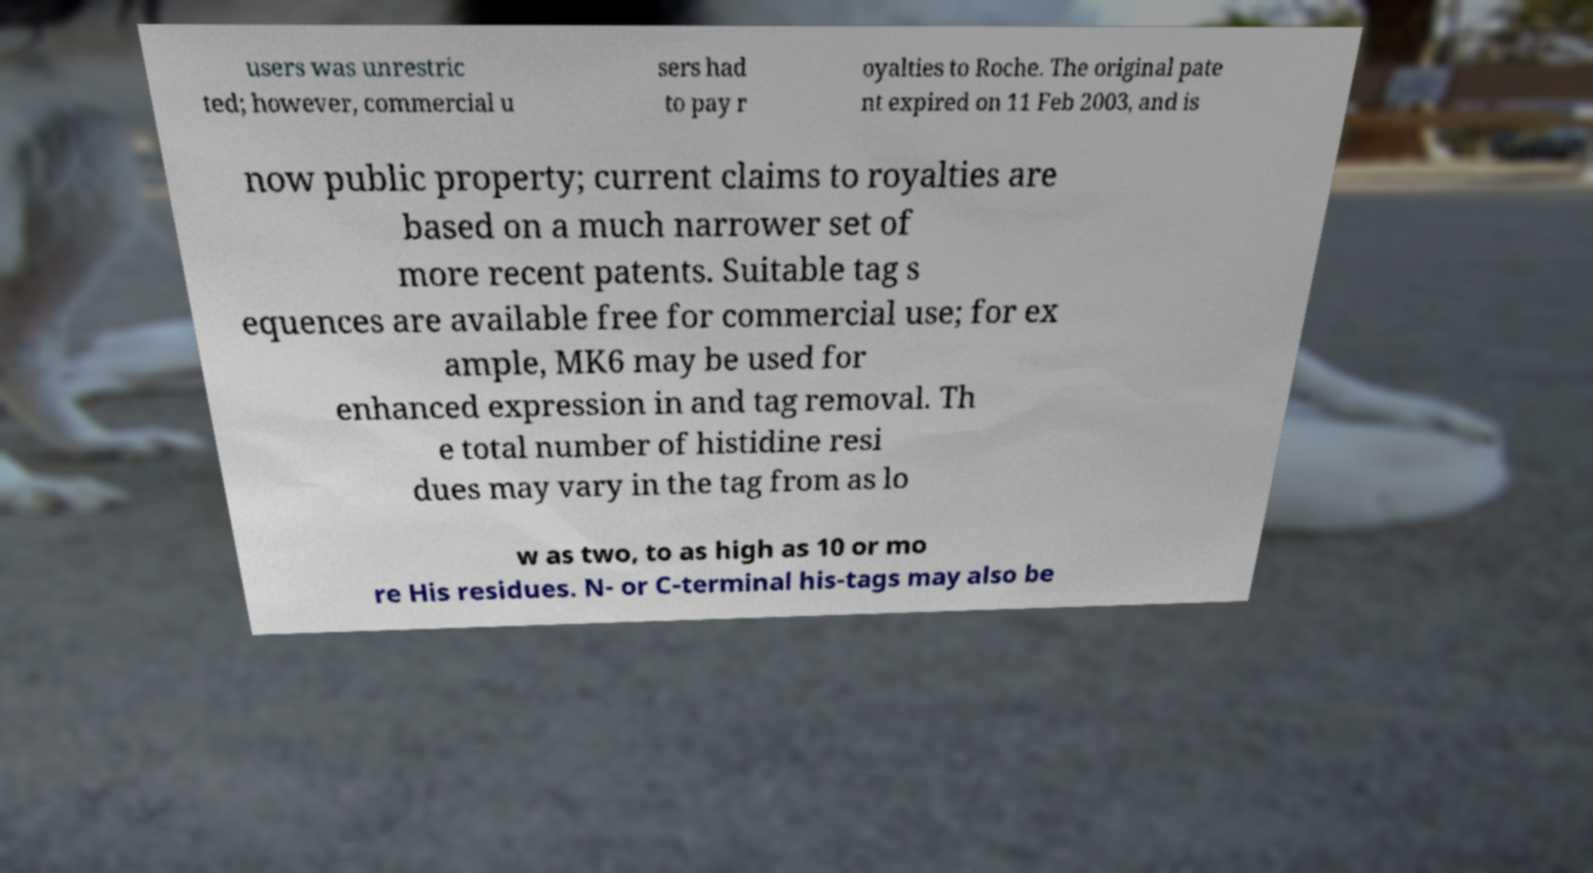I need the written content from this picture converted into text. Can you do that? users was unrestric ted; however, commercial u sers had to pay r oyalties to Roche. The original pate nt expired on 11 Feb 2003, and is now public property; current claims to royalties are based on a much narrower set of more recent patents. Suitable tag s equences are available free for commercial use; for ex ample, MK6 may be used for enhanced expression in and tag removal. Th e total number of histidine resi dues may vary in the tag from as lo w as two, to as high as 10 or mo re His residues. N- or C-terminal his-tags may also be 